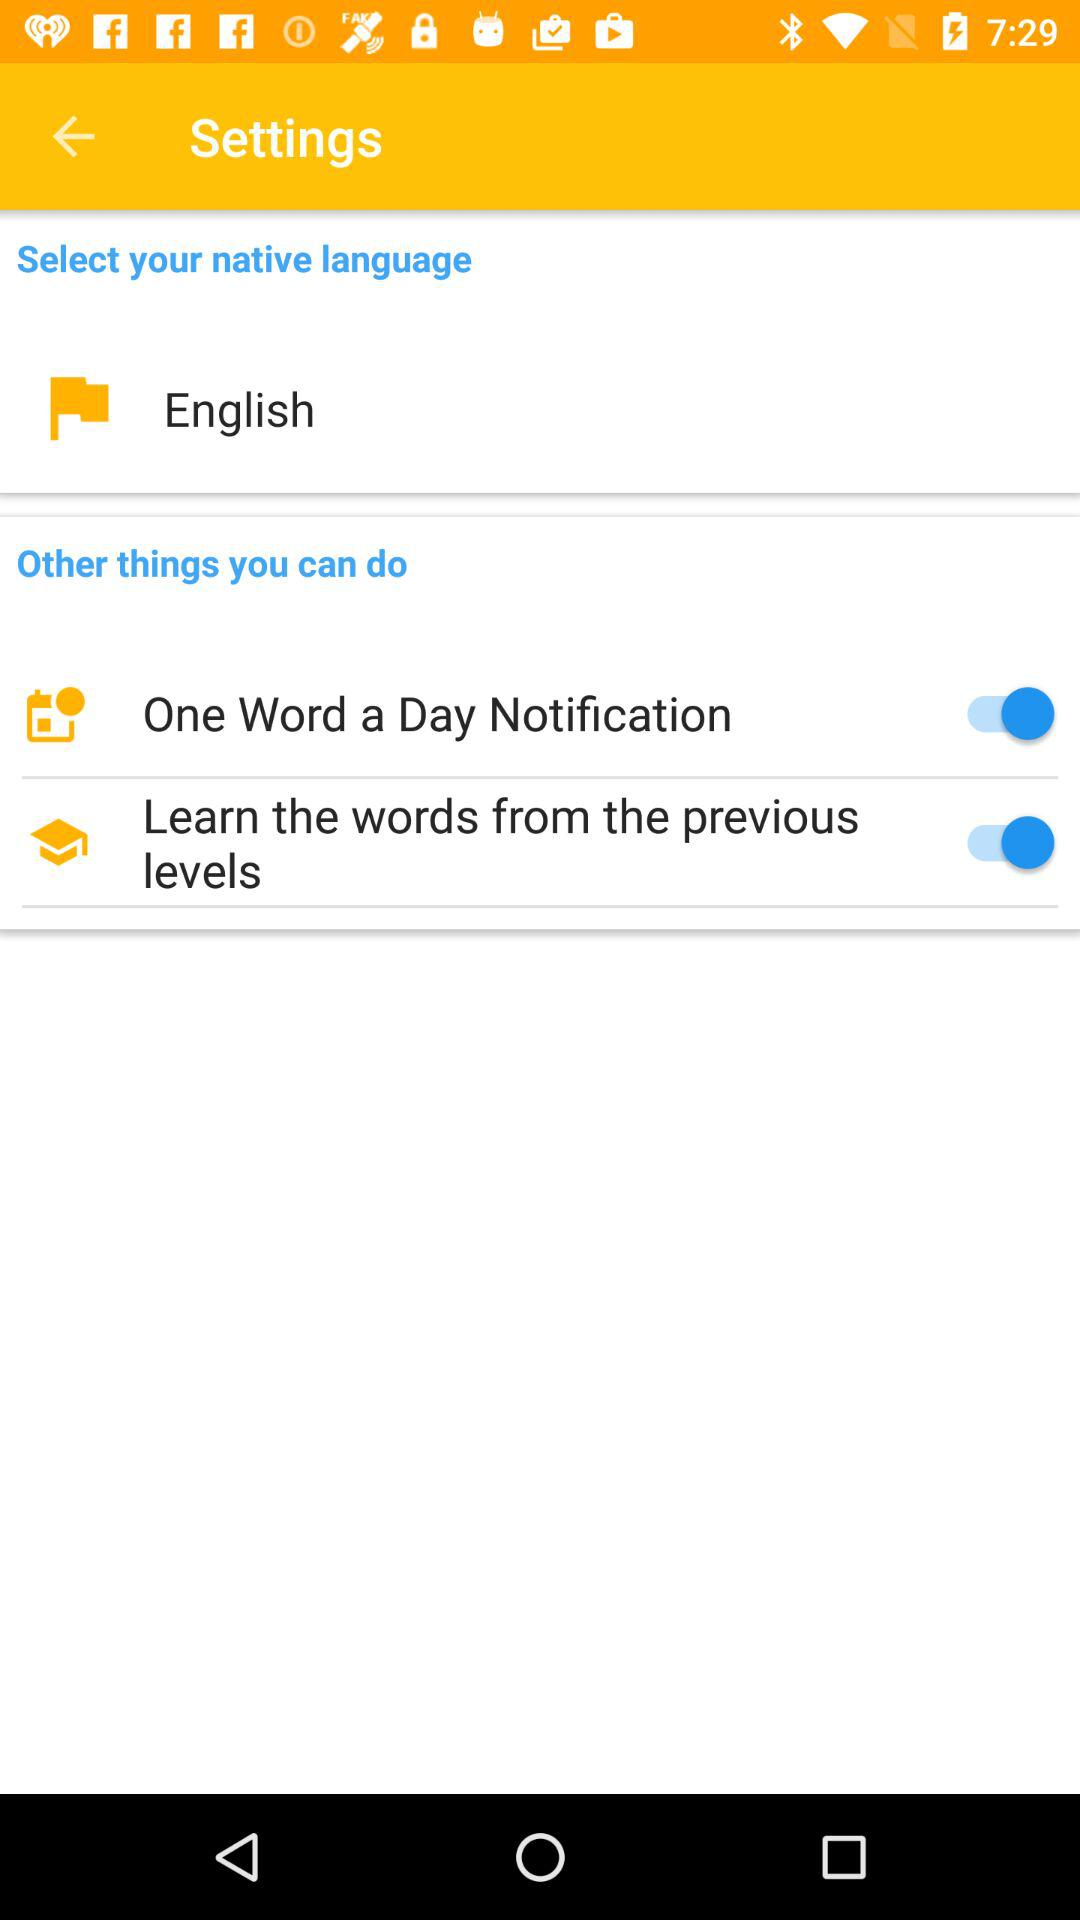What is the status of "One Word a Day Notification"? The status of "One Word a Day Notification" is "on". 